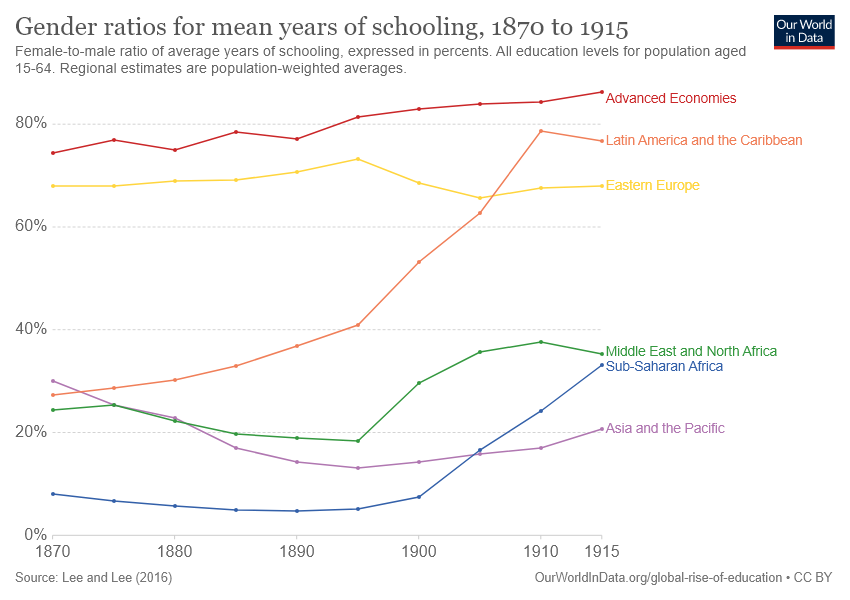List a handful of essential elements in this visual. Advanced economies have consistently had the highest gender ratios for mean years of schooling over the years. The Sub-Saharan Africa, Asia, and the Pacific regions intersect at one point. 